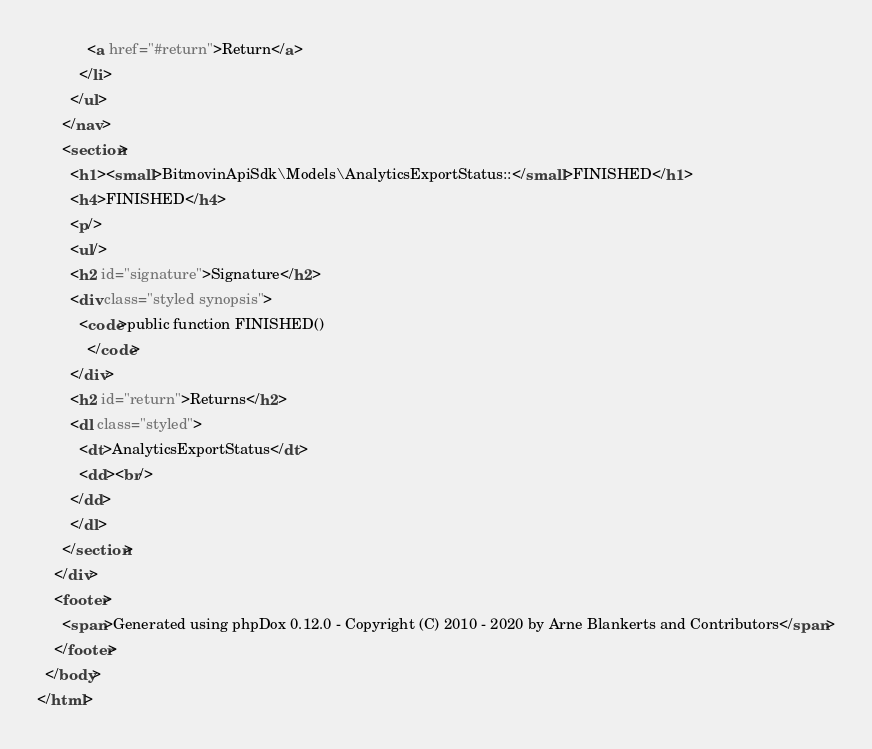Convert code to text. <code><loc_0><loc_0><loc_500><loc_500><_HTML_>            <a href="#return">Return</a>
          </li>
        </ul>
      </nav>
      <section>
        <h1><small>BitmovinApiSdk\Models\AnalyticsExportStatus::</small>FINISHED</h1>
        <h4>FINISHED</h4>
        <p/>
        <ul/>
        <h2 id="signature">Signature</h2>
        <div class="styled synopsis">
          <code>public function FINISHED()
            </code>
        </div>
        <h2 id="return">Returns</h2>
        <dl class="styled">
          <dt>AnalyticsExportStatus</dt>
          <dd><br/>
        </dd>
        </dl>
      </section>
    </div>
    <footer>
      <span>Generated using phpDox 0.12.0 - Copyright (C) 2010 - 2020 by Arne Blankerts and Contributors</span>
    </footer>
  </body>
</html>
</code> 